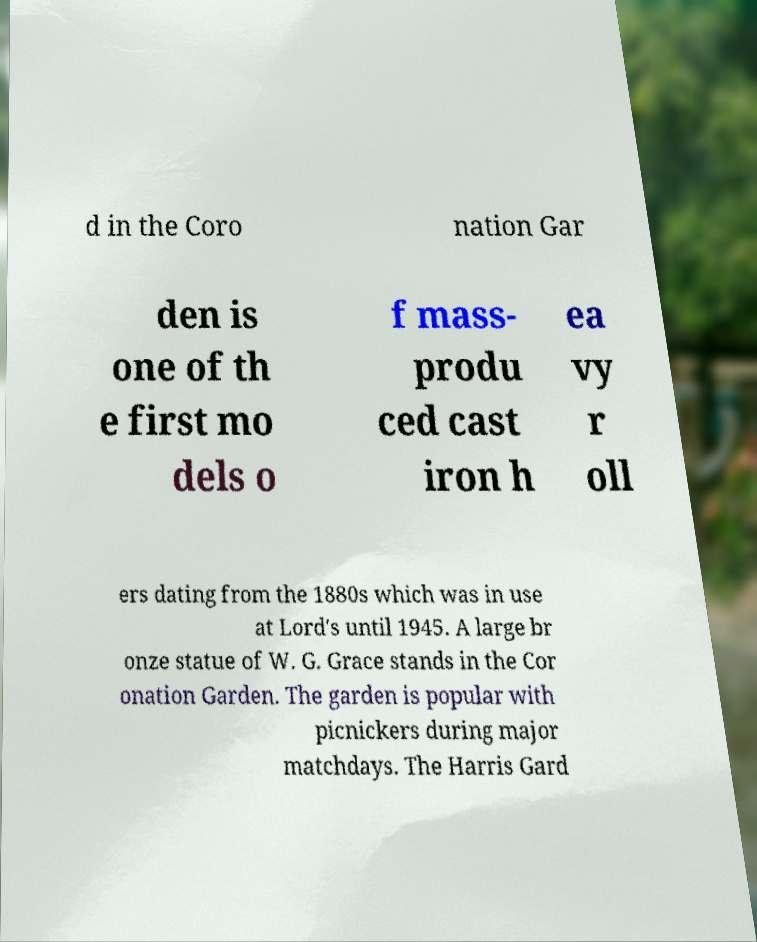Please read and relay the text visible in this image. What does it say? d in the Coro nation Gar den is one of th e first mo dels o f mass- produ ced cast iron h ea vy r oll ers dating from the 1880s which was in use at Lord's until 1945. A large br onze statue of W. G. Grace stands in the Cor onation Garden. The garden is popular with picnickers during major matchdays. The Harris Gard 